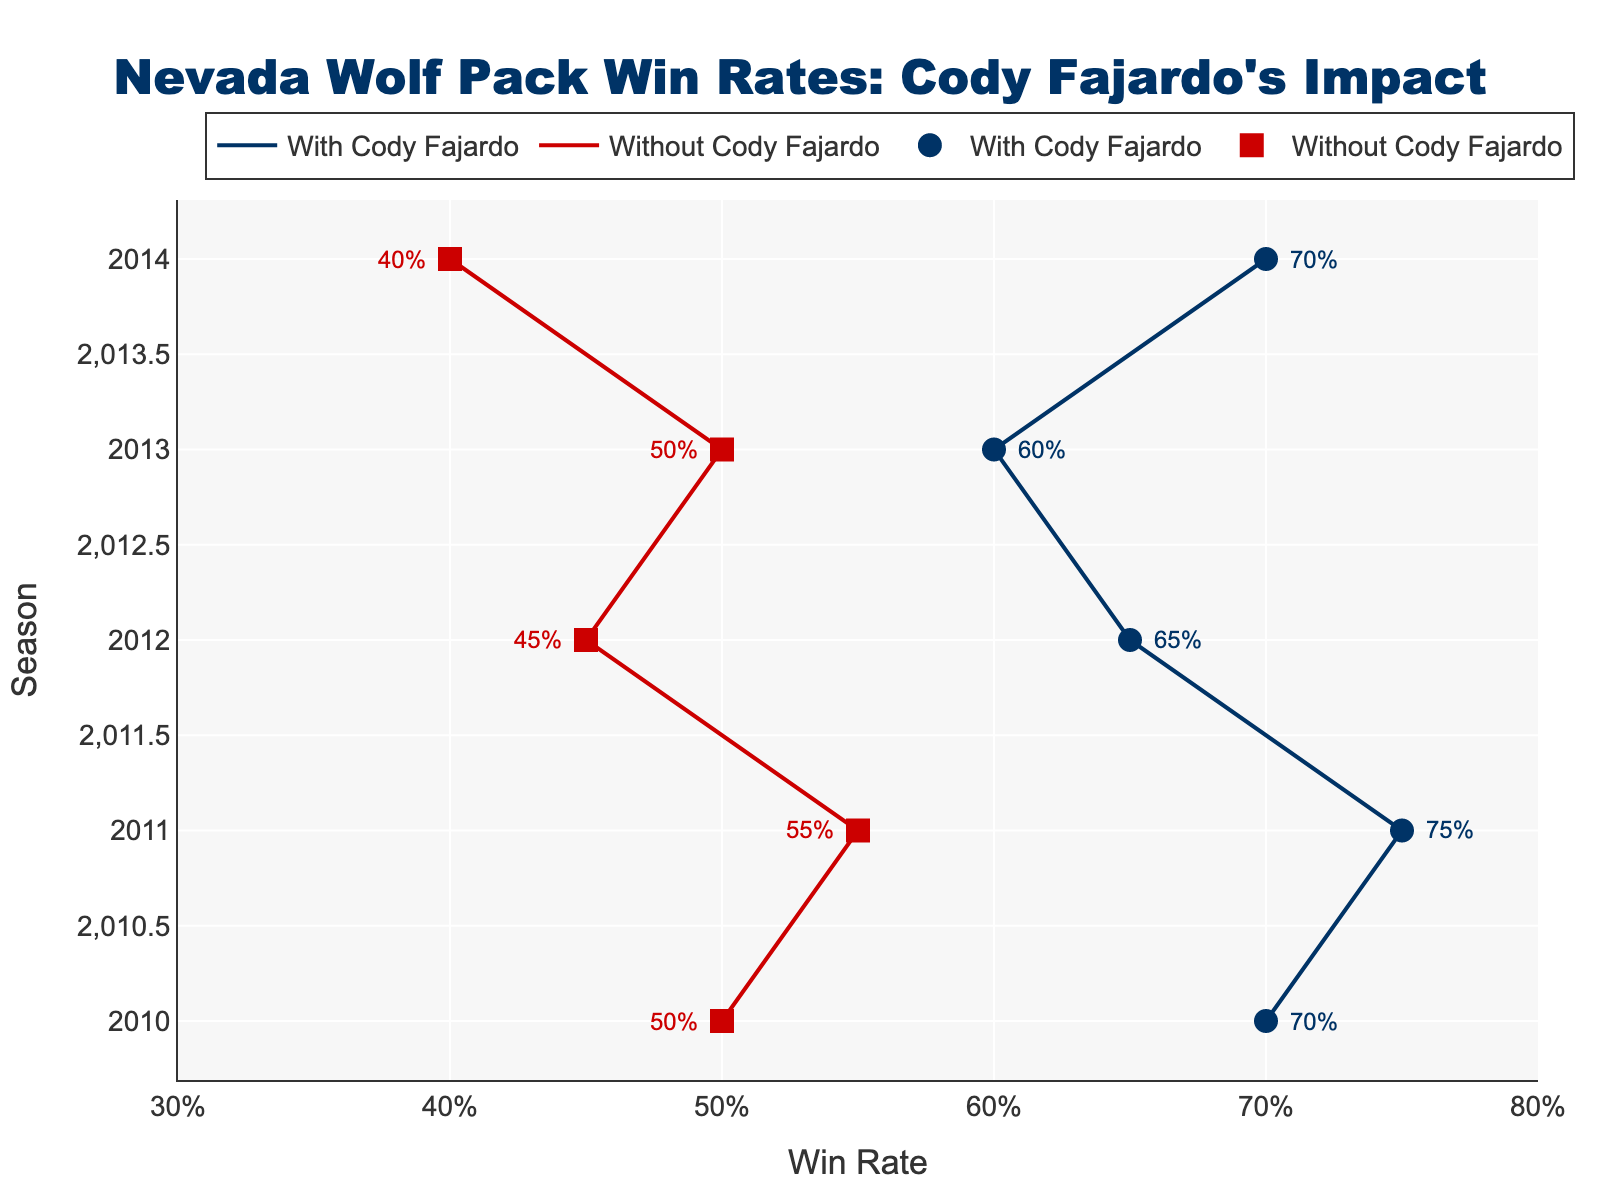What is the title of the plot? The title is located at the top of the plot and typically summarizes what the plot is about. In this case, the title is "Nevada Wolf Pack Win Rates: Cody Fajardo's Impact", as shown in the center top.
Answer: Nevada Wolf Pack Win Rates: Cody Fajardo's Impact What are the two different colors representing in the plot? The colors help differentiate between two categories. Here, the dark blue (#003366) represents "Win Rate with Cody Fajardo" and the red (#CC0000) represents "Win Rate without Cody Fajardo", based on the lines and markers.
Answer: Dark blue and red What was the win rate with Cody Fajardo in the 2014 season? Look for the dark blue marker (circle symbol) on the plot that corresponds to the 2014 season and read the value labeled next to it, which is 70%.
Answer: 70% Which season had the highest win rate without Cody Fajardo? Compare the red markers (square symbols) across all seasons to identify which one has the highest value. The highest win rate without Cody Fajardo is in 2011, with 55%.
Answer: 2011 Was there any season where the win rate without Cody Fajardo was higher than with Cody Fajardo? Examine the plot for any instances where the red square marker is positioned to the right of the blue circle marker in the same season. There are no such instances; the win rate with Cody Fajardo is higher in all seasons.
Answer: No How much higher was the win rate with Cody Fajardo compared to without him in the 2012 season? Subtract the win rate without Cody Fajardo (represented by the red square) from the win rate with him (represented by the blue circle) for the 2012 season. The win rate with Cody Fajardo is 65% and without him is 45%, hence the difference is 65% - 45% = 20%.
Answer: 20% What is the overall trend in the win rate with Cody Fajardo over the seasons? Analyze the position of the blue circle markers over the seasons from 2010 to 2014. The win rates are 70%, 75%, 65%, 60%, and 70% respectively. The trend shows some fluctuation but maintains a generally high win rate.
Answer: Fluctuating What was the win rate difference between the 2011 and 2013 seasons with Cody Fajardo? Subtract the win rate in 2013 (60%) from the win rate in 2011 (75%) with Cody Fajardo. The difference is 75% - 60% = 15%.
Answer: 15% Which season shows the biggest difference in win rates with and without Cody Fajardo? Evaluate each season by comparing the difference between the blue circle and red square markers. The biggest difference is in the 2014 season, with 70% (with Cody) and 40% (without Cody), a 30% difference.
Answer: 2014 What is the pattern of win rates without Cody Fajardo over the seasons? Note the positions of the red markers from 2010 to 2014. The values are 50%, 55%, 45%, 50%, and 40%, which show a slight decrease over the seasons with some fluctuation.
Answer: Slight decrease 